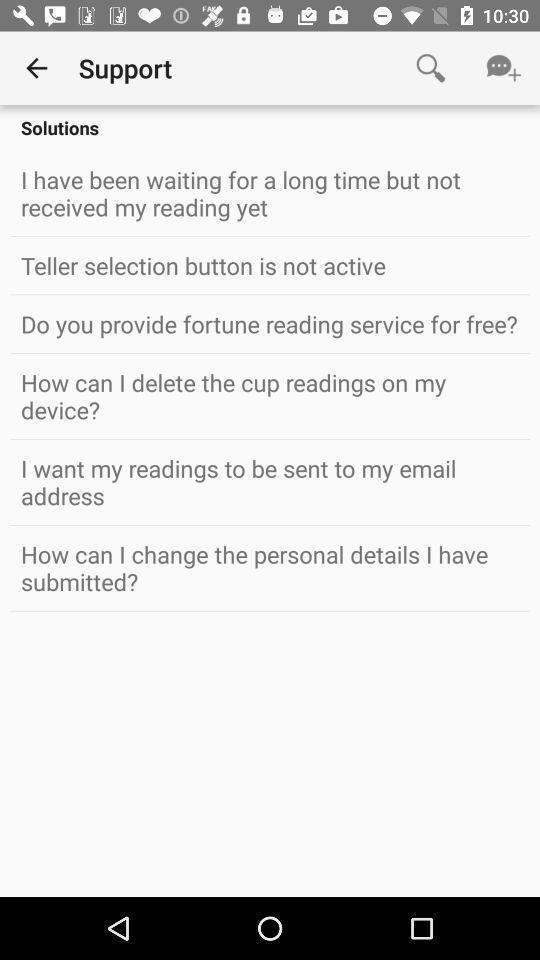Please provide a description for this image. Screen displaying a contact support. 